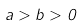Convert formula to latex. <formula><loc_0><loc_0><loc_500><loc_500>a > b > 0</formula> 